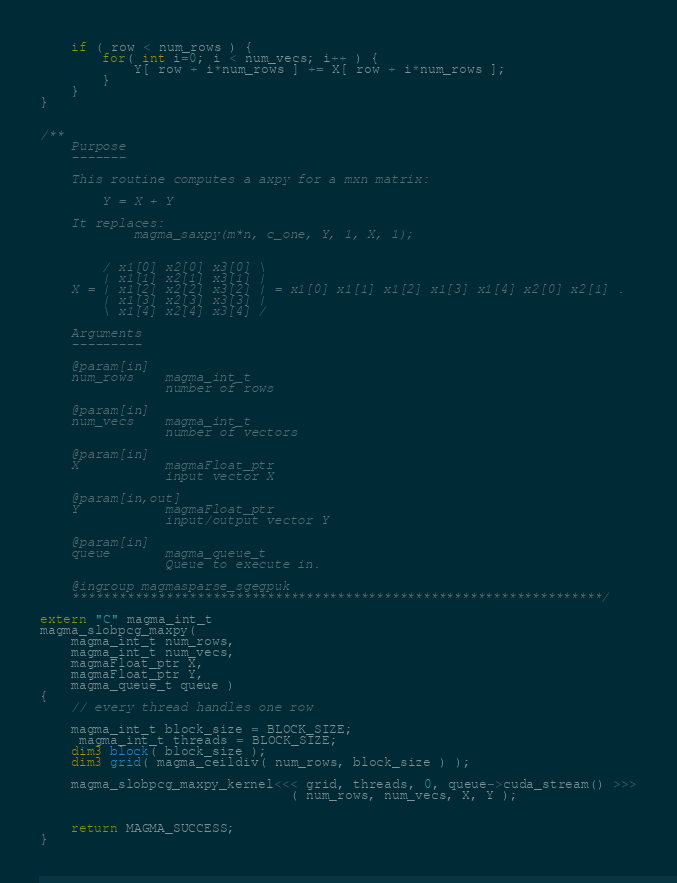Convert code to text. <code><loc_0><loc_0><loc_500><loc_500><_Cuda_>    if ( row < num_rows ) {
        for( int i=0; i < num_vecs; i++ ) {
            Y[ row + i*num_rows ] += X[ row + i*num_rows ];
        }
    }
}


/**
    Purpose
    -------
    
    This routine computes a axpy for a mxn matrix:
        
        Y = X + Y
        
    It replaces:
            magma_saxpy(m*n, c_one, Y, 1, X, 1);


        / x1[0] x2[0] x3[0] \
        | x1[1] x2[1] x3[1] |
    X = | x1[2] x2[2] x3[2] | = x1[0] x1[1] x1[2] x1[3] x1[4] x2[0] x2[1] .
        | x1[3] x2[3] x3[3] |
        \ x1[4] x2[4] x3[4] /
    
    Arguments
    ---------

    @param[in]
    num_rows    magma_int_t
                number of rows

    @param[in]
    num_vecs    magma_int_t
                number of vectors

    @param[in]
    X           magmaFloat_ptr 
                input vector X

    @param[in,out]
    Y           magmaFloat_ptr 
                input/output vector Y

    @param[in]
    queue       magma_queue_t
                Queue to execute in.

    @ingroup magmasparse_sgegpuk
    ********************************************************************/

extern "C" magma_int_t
magma_slobpcg_maxpy(
    magma_int_t num_rows,
    magma_int_t num_vecs, 
    magmaFloat_ptr X,
    magmaFloat_ptr Y,
    magma_queue_t queue )
{
    // every thread handles one row

    magma_int_t block_size = BLOCK_SIZE;
     magma_int_t threads = BLOCK_SIZE;
    dim3 block( block_size );
    dim3 grid( magma_ceildiv( num_rows, block_size ) );

    magma_slobpcg_maxpy_kernel<<< grid, threads, 0, queue->cuda_stream() >>>
                                ( num_rows, num_vecs, X, Y );


    return MAGMA_SUCCESS;
}
</code> 